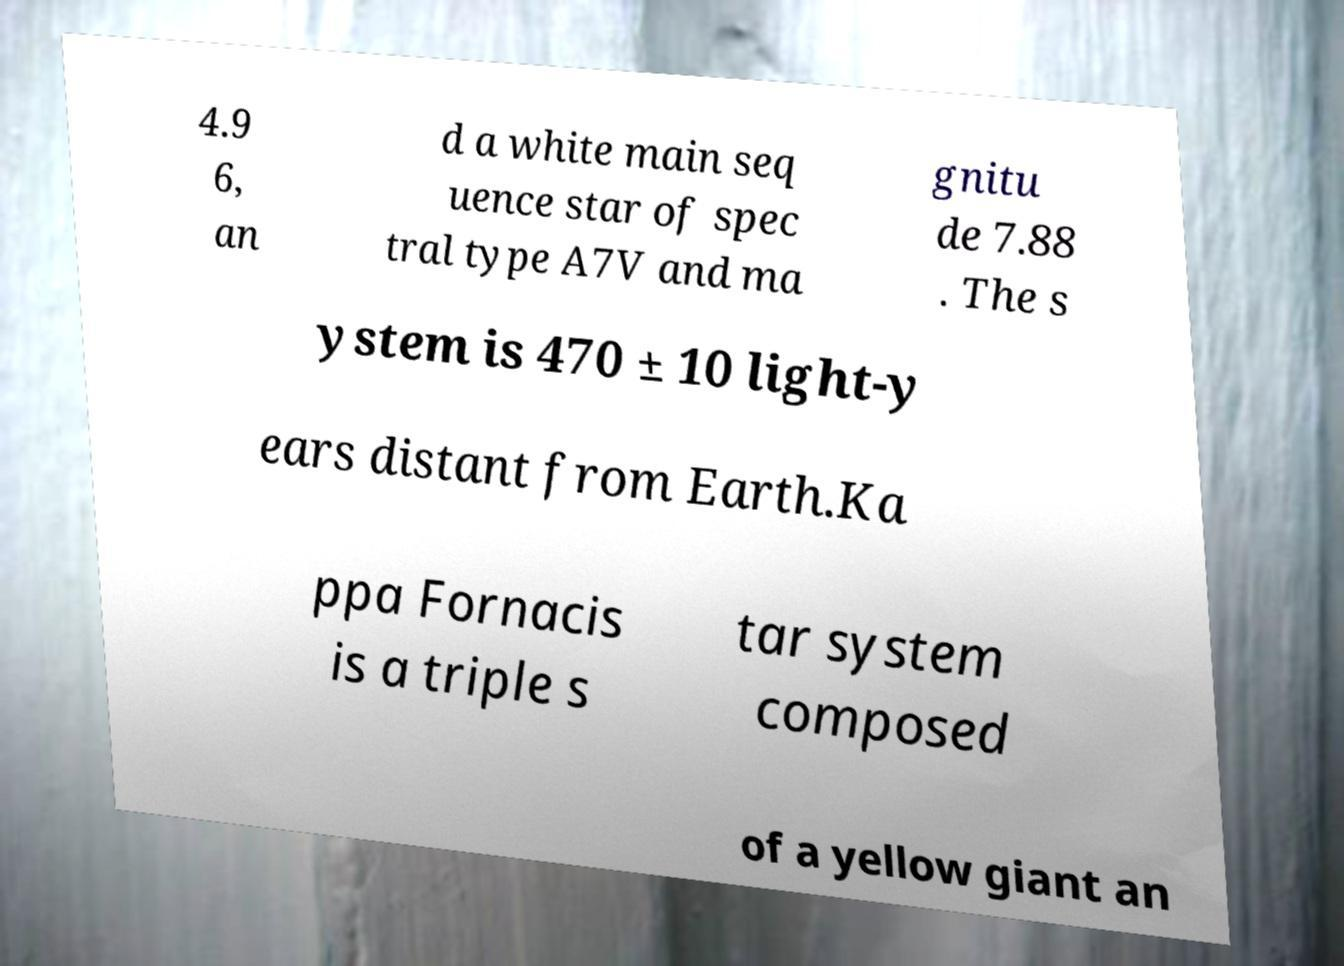What messages or text are displayed in this image? I need them in a readable, typed format. 4.9 6, an d a white main seq uence star of spec tral type A7V and ma gnitu de 7.88 . The s ystem is 470 ± 10 light-y ears distant from Earth.Ka ppa Fornacis is a triple s tar system composed of a yellow giant an 